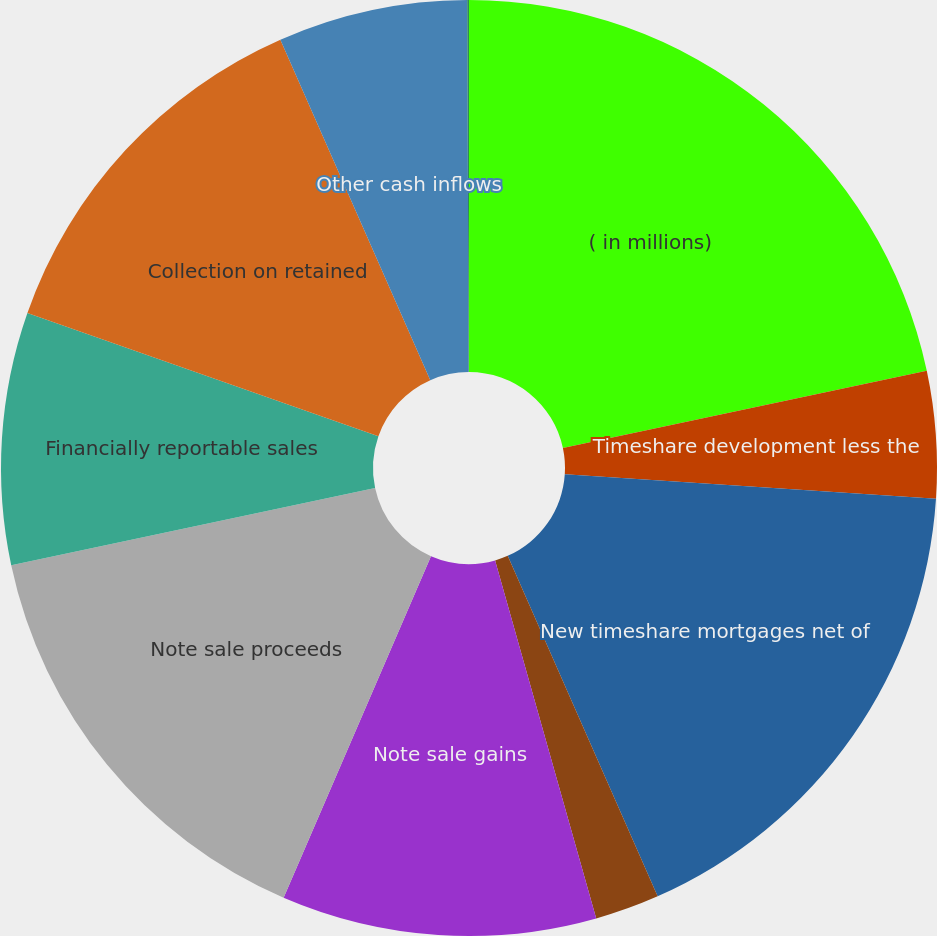Convert chart to OTSL. <chart><loc_0><loc_0><loc_500><loc_500><pie_chart><fcel>( in millions)<fcel>Timeshare development less the<fcel>New timeshare mortgages net of<fcel>Loan repurchases<fcel>Note sale gains<fcel>Note sale proceeds<fcel>Financially reportable sales<fcel>Collection on retained<fcel>Other cash inflows<fcel>Net cash (outflows) inflows<nl><fcel>21.66%<fcel>4.38%<fcel>17.34%<fcel>2.22%<fcel>10.86%<fcel>15.18%<fcel>8.7%<fcel>13.02%<fcel>6.54%<fcel>0.06%<nl></chart> 